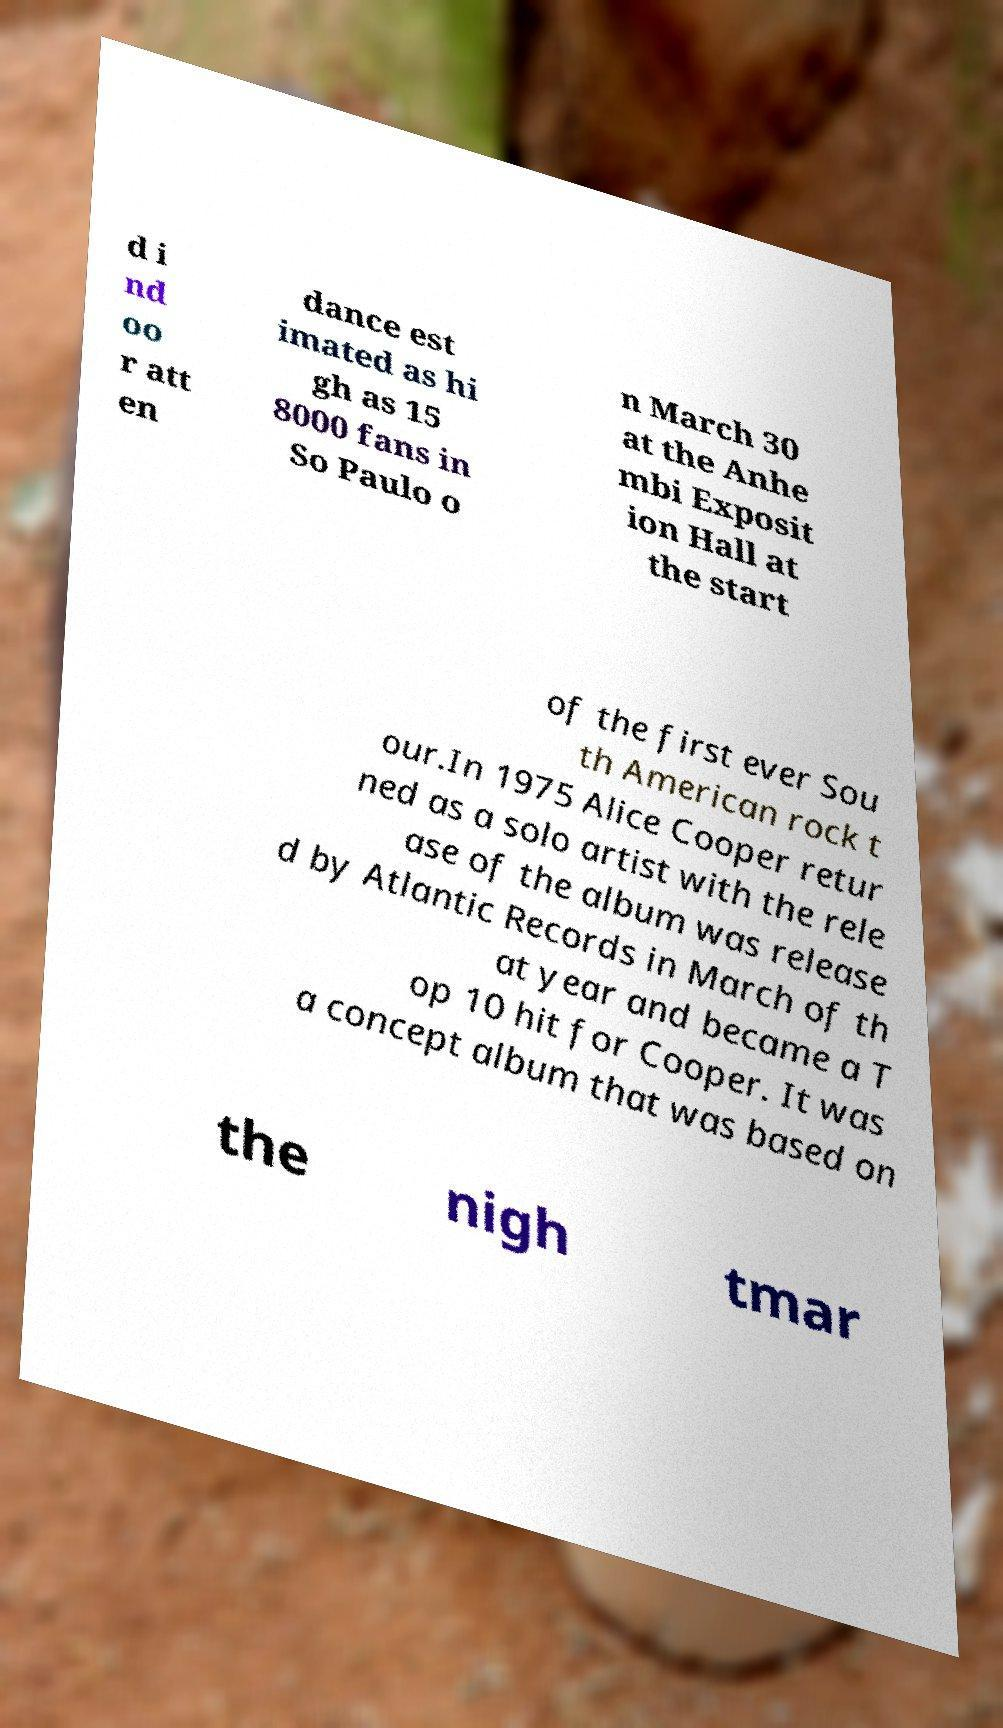What messages or text are displayed in this image? I need them in a readable, typed format. d i nd oo r att en dance est imated as hi gh as 15 8000 fans in So Paulo o n March 30 at the Anhe mbi Exposit ion Hall at the start of the first ever Sou th American rock t our.In 1975 Alice Cooper retur ned as a solo artist with the rele ase of the album was release d by Atlantic Records in March of th at year and became a T op 10 hit for Cooper. It was a concept album that was based on the nigh tmar 